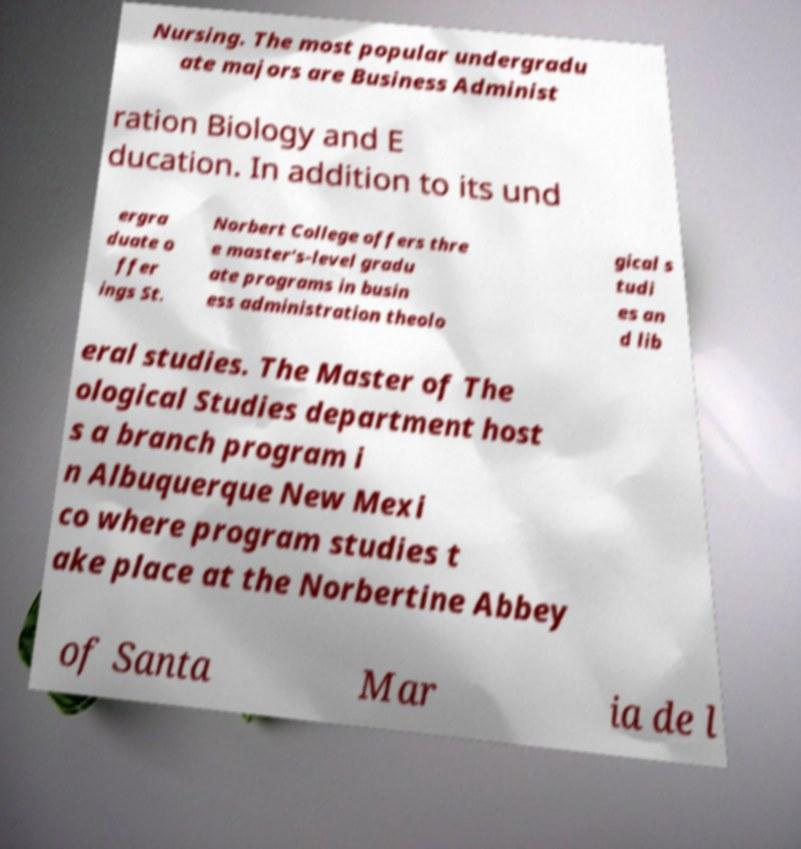Please read and relay the text visible in this image. What does it say? Nursing. The most popular undergradu ate majors are Business Administ ration Biology and E ducation. In addition to its und ergra duate o ffer ings St. Norbert College offers thre e master's-level gradu ate programs in busin ess administration theolo gical s tudi es an d lib eral studies. The Master of The ological Studies department host s a branch program i n Albuquerque New Mexi co where program studies t ake place at the Norbertine Abbey of Santa Mar ia de l 